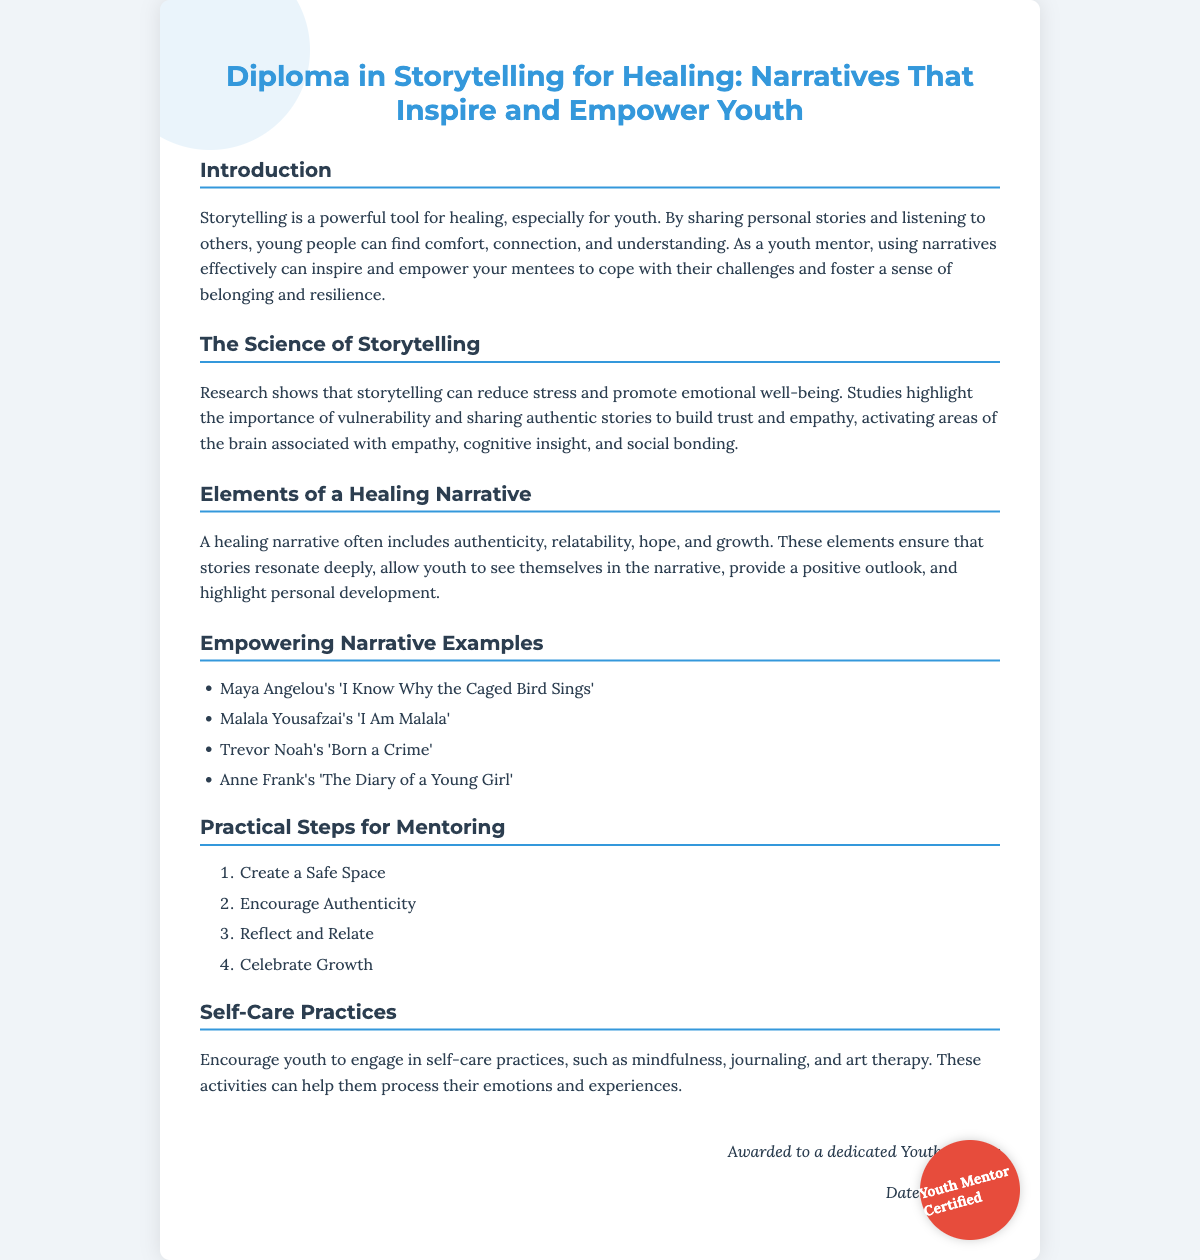What is the title of the diploma? The title is presented prominently at the top of the document.
Answer: Diploma in Storytelling for Healing: Narratives That Inspire and Empower Youth What is one key component of storytelling that promotes emotional well-being? This is highlighted in the section discussing the science of storytelling.
Answer: Vulnerability Who is the author of 'I Know Why the Caged Bird Sings'? This question pertains to the examples provided in the healing narratives section.
Answer: Maya Angelou What should mentors create to facilitate storytelling? This is mentioned in the practical steps for mentoring section.
Answer: A Safe Space Which self-care practice is suggested in the document? This is found in the self-care practices section.
Answer: Mindfulness What are the elements of a healing narrative? The document lists these elements in the corresponding section.
Answer: Authenticity, relatability, hope, and growth How many practical steps for mentoring are provided? This is a simple count found in the practical steps section.
Answer: Four What do the stories help foster among youth? This reflects the overall goal outlined in the introduction section.
Answer: Resilience 